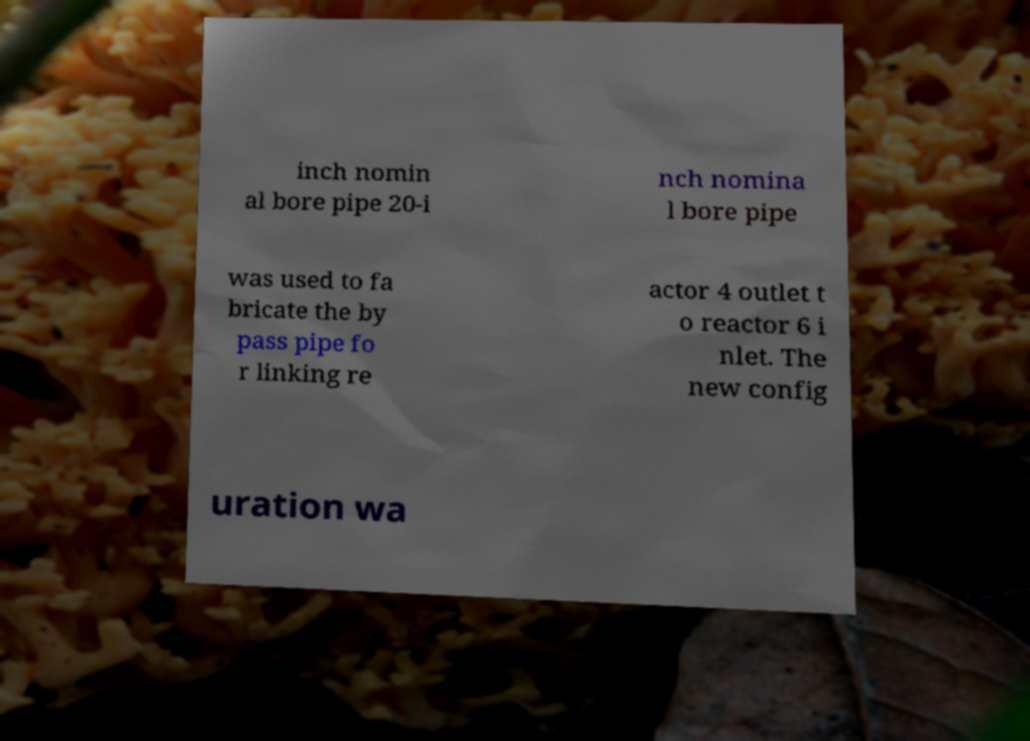Please identify and transcribe the text found in this image. inch nomin al bore pipe 20-i nch nomina l bore pipe was used to fa bricate the by pass pipe fo r linking re actor 4 outlet t o reactor 6 i nlet. The new config uration wa 